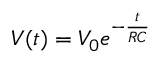Convert formula to latex. <formula><loc_0><loc_0><loc_500><loc_500>V ( t ) = V _ { 0 } e ^ { - \frac { t } { R C } }</formula> 